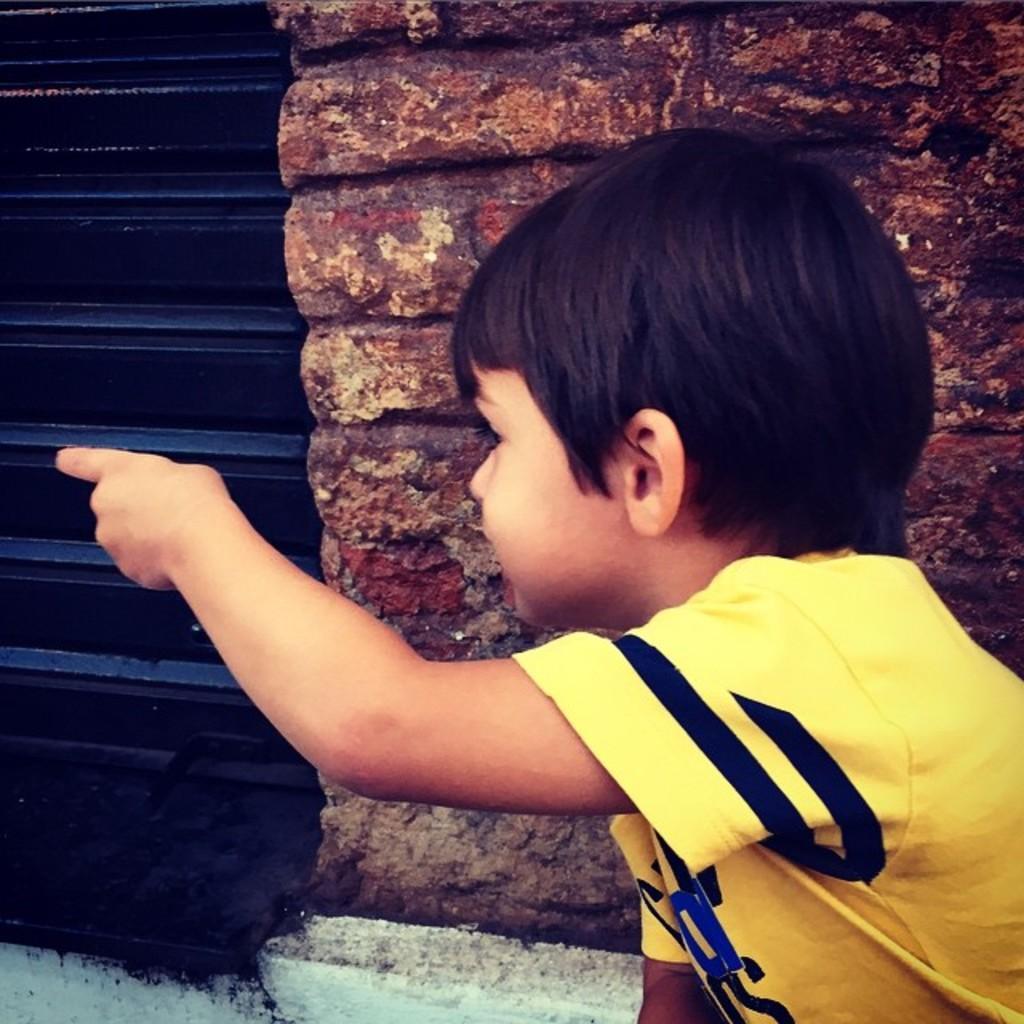Describe this image in one or two sentences. In the image there is a kid in yellow t-shirt showing finger to the left direction, behind him there is a wall and a shutter, 